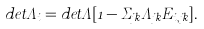<formula> <loc_0><loc_0><loc_500><loc_500>d e t \Lambda _ { i } = d e t \Lambda [ 1 - \Sigma _ { j k } \Lambda _ { j k } E _ { i , j k } ] .</formula> 